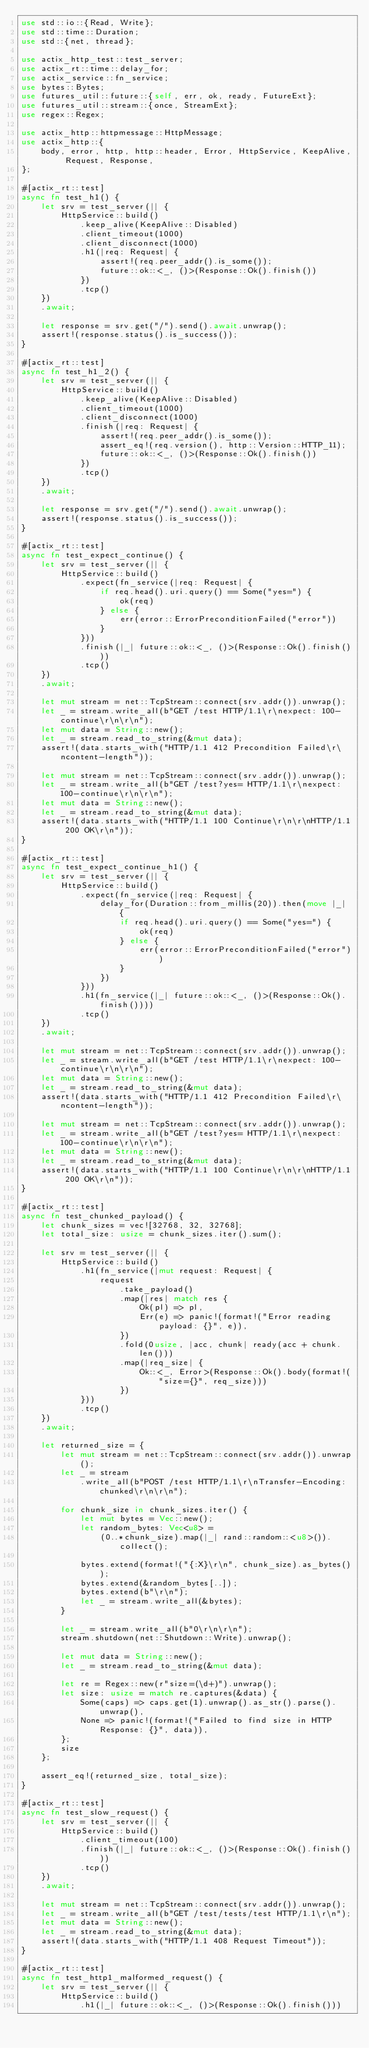<code> <loc_0><loc_0><loc_500><loc_500><_Rust_>use std::io::{Read, Write};
use std::time::Duration;
use std::{net, thread};

use actix_http_test::test_server;
use actix_rt::time::delay_for;
use actix_service::fn_service;
use bytes::Bytes;
use futures_util::future::{self, err, ok, ready, FutureExt};
use futures_util::stream::{once, StreamExt};
use regex::Regex;

use actix_http::httpmessage::HttpMessage;
use actix_http::{
    body, error, http, http::header, Error, HttpService, KeepAlive, Request, Response,
};

#[actix_rt::test]
async fn test_h1() {
    let srv = test_server(|| {
        HttpService::build()
            .keep_alive(KeepAlive::Disabled)
            .client_timeout(1000)
            .client_disconnect(1000)
            .h1(|req: Request| {
                assert!(req.peer_addr().is_some());
                future::ok::<_, ()>(Response::Ok().finish())
            })
            .tcp()
    })
    .await;

    let response = srv.get("/").send().await.unwrap();
    assert!(response.status().is_success());
}

#[actix_rt::test]
async fn test_h1_2() {
    let srv = test_server(|| {
        HttpService::build()
            .keep_alive(KeepAlive::Disabled)
            .client_timeout(1000)
            .client_disconnect(1000)
            .finish(|req: Request| {
                assert!(req.peer_addr().is_some());
                assert_eq!(req.version(), http::Version::HTTP_11);
                future::ok::<_, ()>(Response::Ok().finish())
            })
            .tcp()
    })
    .await;

    let response = srv.get("/").send().await.unwrap();
    assert!(response.status().is_success());
}

#[actix_rt::test]
async fn test_expect_continue() {
    let srv = test_server(|| {
        HttpService::build()
            .expect(fn_service(|req: Request| {
                if req.head().uri.query() == Some("yes=") {
                    ok(req)
                } else {
                    err(error::ErrorPreconditionFailed("error"))
                }
            }))
            .finish(|_| future::ok::<_, ()>(Response::Ok().finish()))
            .tcp()
    })
    .await;

    let mut stream = net::TcpStream::connect(srv.addr()).unwrap();
    let _ = stream.write_all(b"GET /test HTTP/1.1\r\nexpect: 100-continue\r\n\r\n");
    let mut data = String::new();
    let _ = stream.read_to_string(&mut data);
    assert!(data.starts_with("HTTP/1.1 412 Precondition Failed\r\ncontent-length"));

    let mut stream = net::TcpStream::connect(srv.addr()).unwrap();
    let _ = stream.write_all(b"GET /test?yes= HTTP/1.1\r\nexpect: 100-continue\r\n\r\n");
    let mut data = String::new();
    let _ = stream.read_to_string(&mut data);
    assert!(data.starts_with("HTTP/1.1 100 Continue\r\n\r\nHTTP/1.1 200 OK\r\n"));
}

#[actix_rt::test]
async fn test_expect_continue_h1() {
    let srv = test_server(|| {
        HttpService::build()
            .expect(fn_service(|req: Request| {
                delay_for(Duration::from_millis(20)).then(move |_| {
                    if req.head().uri.query() == Some("yes=") {
                        ok(req)
                    } else {
                        err(error::ErrorPreconditionFailed("error"))
                    }
                })
            }))
            .h1(fn_service(|_| future::ok::<_, ()>(Response::Ok().finish())))
            .tcp()
    })
    .await;

    let mut stream = net::TcpStream::connect(srv.addr()).unwrap();
    let _ = stream.write_all(b"GET /test HTTP/1.1\r\nexpect: 100-continue\r\n\r\n");
    let mut data = String::new();
    let _ = stream.read_to_string(&mut data);
    assert!(data.starts_with("HTTP/1.1 412 Precondition Failed\r\ncontent-length"));

    let mut stream = net::TcpStream::connect(srv.addr()).unwrap();
    let _ = stream.write_all(b"GET /test?yes= HTTP/1.1\r\nexpect: 100-continue\r\n\r\n");
    let mut data = String::new();
    let _ = stream.read_to_string(&mut data);
    assert!(data.starts_with("HTTP/1.1 100 Continue\r\n\r\nHTTP/1.1 200 OK\r\n"));
}

#[actix_rt::test]
async fn test_chunked_payload() {
    let chunk_sizes = vec![32768, 32, 32768];
    let total_size: usize = chunk_sizes.iter().sum();

    let srv = test_server(|| {
        HttpService::build()
            .h1(fn_service(|mut request: Request| {
                request
                    .take_payload()
                    .map(|res| match res {
                        Ok(pl) => pl,
                        Err(e) => panic!(format!("Error reading payload: {}", e)),
                    })
                    .fold(0usize, |acc, chunk| ready(acc + chunk.len()))
                    .map(|req_size| {
                        Ok::<_, Error>(Response::Ok().body(format!("size={}", req_size)))
                    })
            }))
            .tcp()
    })
    .await;

    let returned_size = {
        let mut stream = net::TcpStream::connect(srv.addr()).unwrap();
        let _ = stream
            .write_all(b"POST /test HTTP/1.1\r\nTransfer-Encoding: chunked\r\n\r\n");

        for chunk_size in chunk_sizes.iter() {
            let mut bytes = Vec::new();
            let random_bytes: Vec<u8> =
                (0..*chunk_size).map(|_| rand::random::<u8>()).collect();

            bytes.extend(format!("{:X}\r\n", chunk_size).as_bytes());
            bytes.extend(&random_bytes[..]);
            bytes.extend(b"\r\n");
            let _ = stream.write_all(&bytes);
        }

        let _ = stream.write_all(b"0\r\n\r\n");
        stream.shutdown(net::Shutdown::Write).unwrap();

        let mut data = String::new();
        let _ = stream.read_to_string(&mut data);

        let re = Regex::new(r"size=(\d+)").unwrap();
        let size: usize = match re.captures(&data) {
            Some(caps) => caps.get(1).unwrap().as_str().parse().unwrap(),
            None => panic!(format!("Failed to find size in HTTP Response: {}", data)),
        };
        size
    };

    assert_eq!(returned_size, total_size);
}

#[actix_rt::test]
async fn test_slow_request() {
    let srv = test_server(|| {
        HttpService::build()
            .client_timeout(100)
            .finish(|_| future::ok::<_, ()>(Response::Ok().finish()))
            .tcp()
    })
    .await;

    let mut stream = net::TcpStream::connect(srv.addr()).unwrap();
    let _ = stream.write_all(b"GET /test/tests/test HTTP/1.1\r\n");
    let mut data = String::new();
    let _ = stream.read_to_string(&mut data);
    assert!(data.starts_with("HTTP/1.1 408 Request Timeout"));
}

#[actix_rt::test]
async fn test_http1_malformed_request() {
    let srv = test_server(|| {
        HttpService::build()
            .h1(|_| future::ok::<_, ()>(Response::Ok().finish()))</code> 